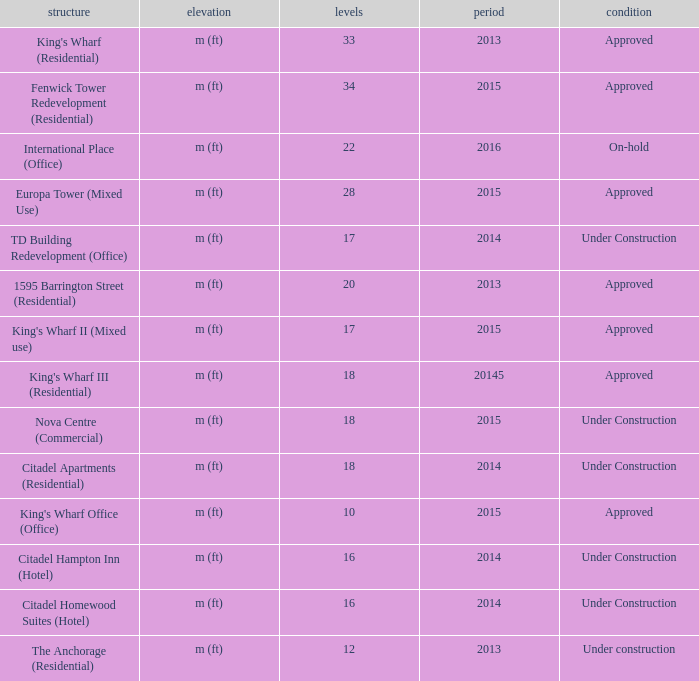What are the number of floors for the building of td building redevelopment (office)? 17.0. 